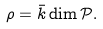Convert formula to latex. <formula><loc_0><loc_0><loc_500><loc_500>\rho = \bar { k } \dim \mathcal { P } .</formula> 